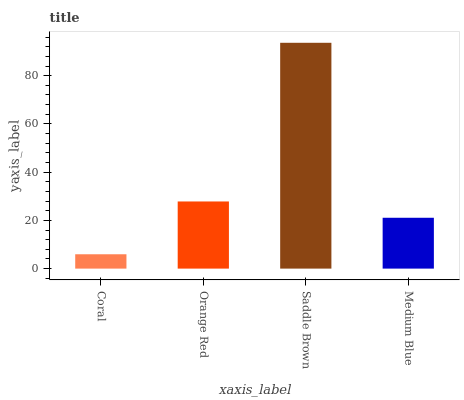Is Coral the minimum?
Answer yes or no. Yes. Is Saddle Brown the maximum?
Answer yes or no. Yes. Is Orange Red the minimum?
Answer yes or no. No. Is Orange Red the maximum?
Answer yes or no. No. Is Orange Red greater than Coral?
Answer yes or no. Yes. Is Coral less than Orange Red?
Answer yes or no. Yes. Is Coral greater than Orange Red?
Answer yes or no. No. Is Orange Red less than Coral?
Answer yes or no. No. Is Orange Red the high median?
Answer yes or no. Yes. Is Medium Blue the low median?
Answer yes or no. Yes. Is Coral the high median?
Answer yes or no. No. Is Orange Red the low median?
Answer yes or no. No. 